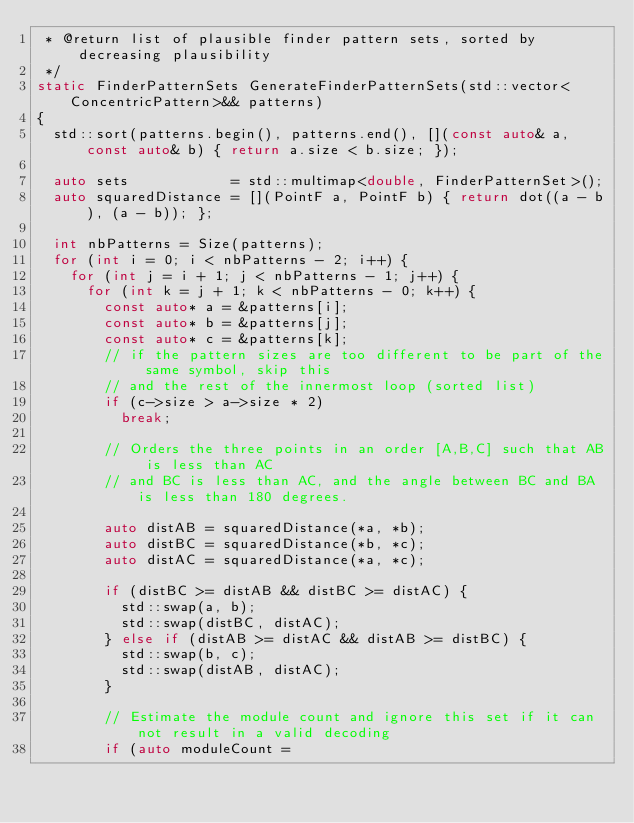<code> <loc_0><loc_0><loc_500><loc_500><_C++_> * @return list of plausible finder pattern sets, sorted by decreasing plausibility
 */
static FinderPatternSets GenerateFinderPatternSets(std::vector<ConcentricPattern>&& patterns)
{
	std::sort(patterns.begin(), patterns.end(), [](const auto& a, const auto& b) { return a.size < b.size; });

	auto sets            = std::multimap<double, FinderPatternSet>();
	auto squaredDistance = [](PointF a, PointF b) { return dot((a - b), (a - b)); };

	int nbPatterns = Size(patterns);
	for (int i = 0; i < nbPatterns - 2; i++) {
		for (int j = i + 1; j < nbPatterns - 1; j++) {
			for (int k = j + 1; k < nbPatterns - 0; k++) {
				const auto* a = &patterns[i];
				const auto* b = &patterns[j];
				const auto* c = &patterns[k];
				// if the pattern sizes are too different to be part of the same symbol, skip this
				// and the rest of the innermost loop (sorted list)
				if (c->size > a->size * 2)
					break;

				// Orders the three points in an order [A,B,C] such that AB is less than AC
				// and BC is less than AC, and the angle between BC and BA is less than 180 degrees.

				auto distAB = squaredDistance(*a, *b);
				auto distBC = squaredDistance(*b, *c);
				auto distAC = squaredDistance(*a, *c);

				if (distBC >= distAB && distBC >= distAC) {
					std::swap(a, b);
					std::swap(distBC, distAC);
				} else if (distAB >= distAC && distAB >= distBC) {
					std::swap(b, c);
					std::swap(distAB, distAC);
				}

				// Estimate the module count and ignore this set if it can not result in a valid decoding
				if (auto moduleCount =</code> 